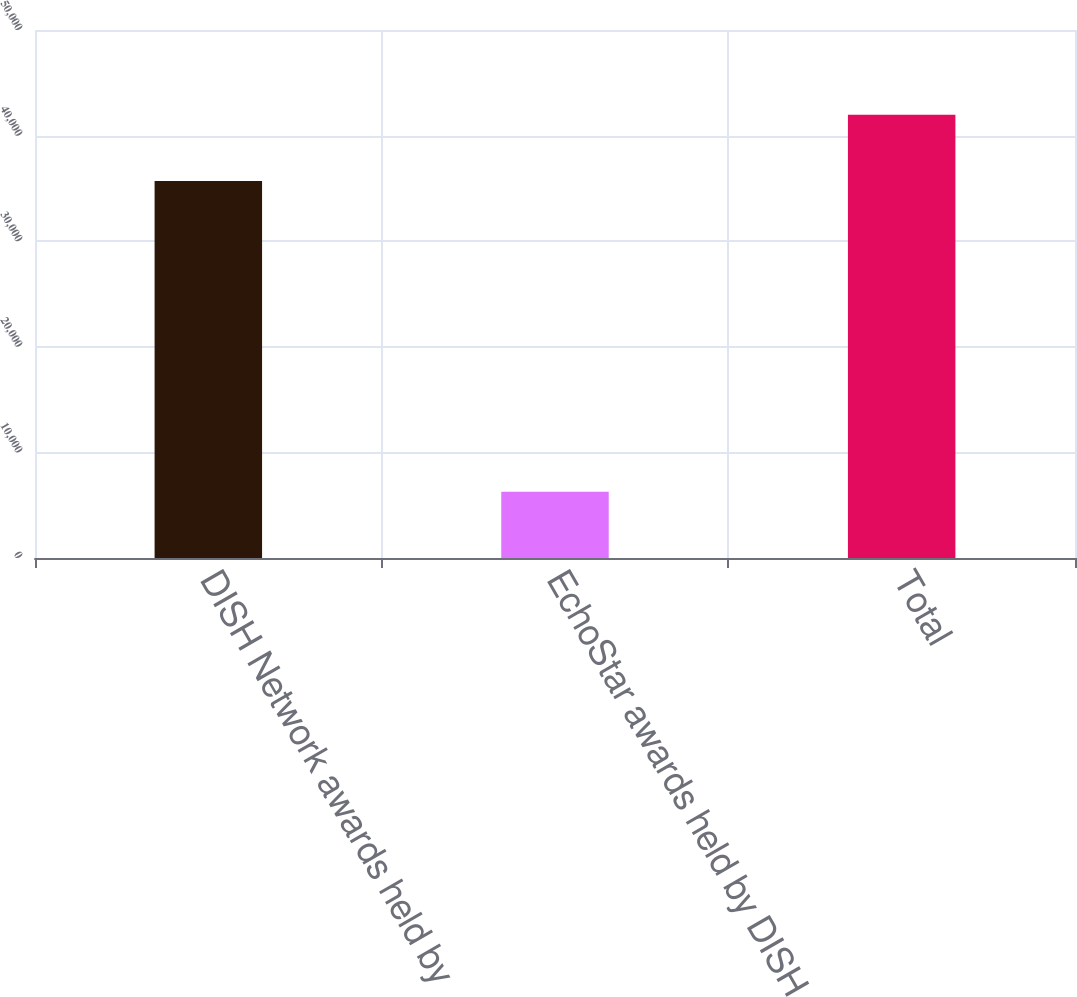Convert chart. <chart><loc_0><loc_0><loc_500><loc_500><bar_chart><fcel>DISH Network awards held by<fcel>EchoStar awards held by DISH<fcel>Total<nl><fcel>35698<fcel>6279<fcel>41977<nl></chart> 